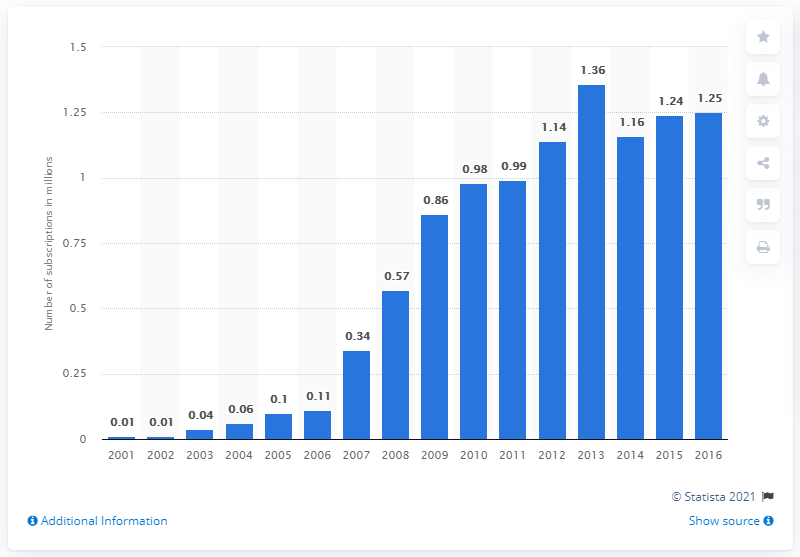List a handful of essential elements in this visual. In 2016, the Central African Republic had 1.25 mobile subscriptions per inhabitant. 